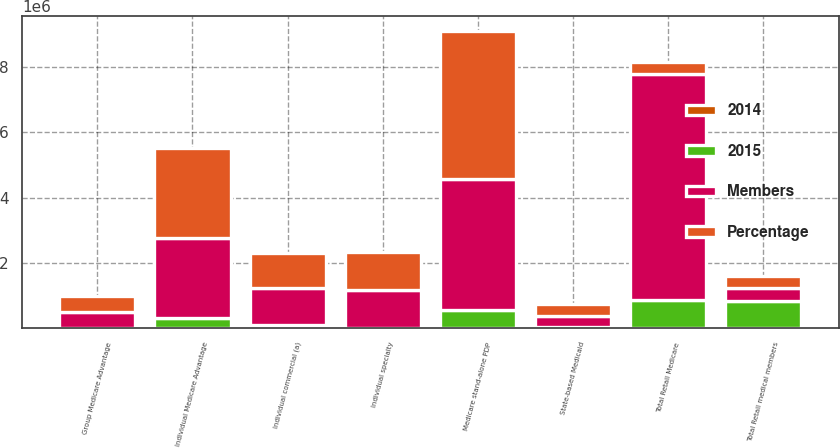<chart> <loc_0><loc_0><loc_500><loc_500><stacked_bar_chart><ecel><fcel>Individual Medicare Advantage<fcel>Group Medicare Advantage<fcel>Medicare stand-alone PDP<fcel>Total Retail Medicare<fcel>Individual commercial (a)<fcel>State-based Medicaid<fcel>Total Retail medical members<fcel>Individual specialty<nl><fcel>Percentage<fcel>2.7534e+06<fcel>484100<fcel>4.5579e+06<fcel>373700<fcel>1.0577e+06<fcel>373700<fcel>373700<fcel>1.1531e+06<nl><fcel>Members<fcel>2.4279e+06<fcel>489700<fcel>3.994e+06<fcel>6.9116e+06<fcel>1.1481e+06<fcel>316800<fcel>373700<fcel>1.1658e+06<nl><fcel>2015<fcel>325500<fcel>5600<fcel>563900<fcel>883800<fcel>90400<fcel>56900<fcel>850300<fcel>12700<nl><fcel>2014<fcel>13.4<fcel>1.1<fcel>14.1<fcel>12.8<fcel>7.9<fcel>18<fcel>10.2<fcel>1.1<nl></chart> 